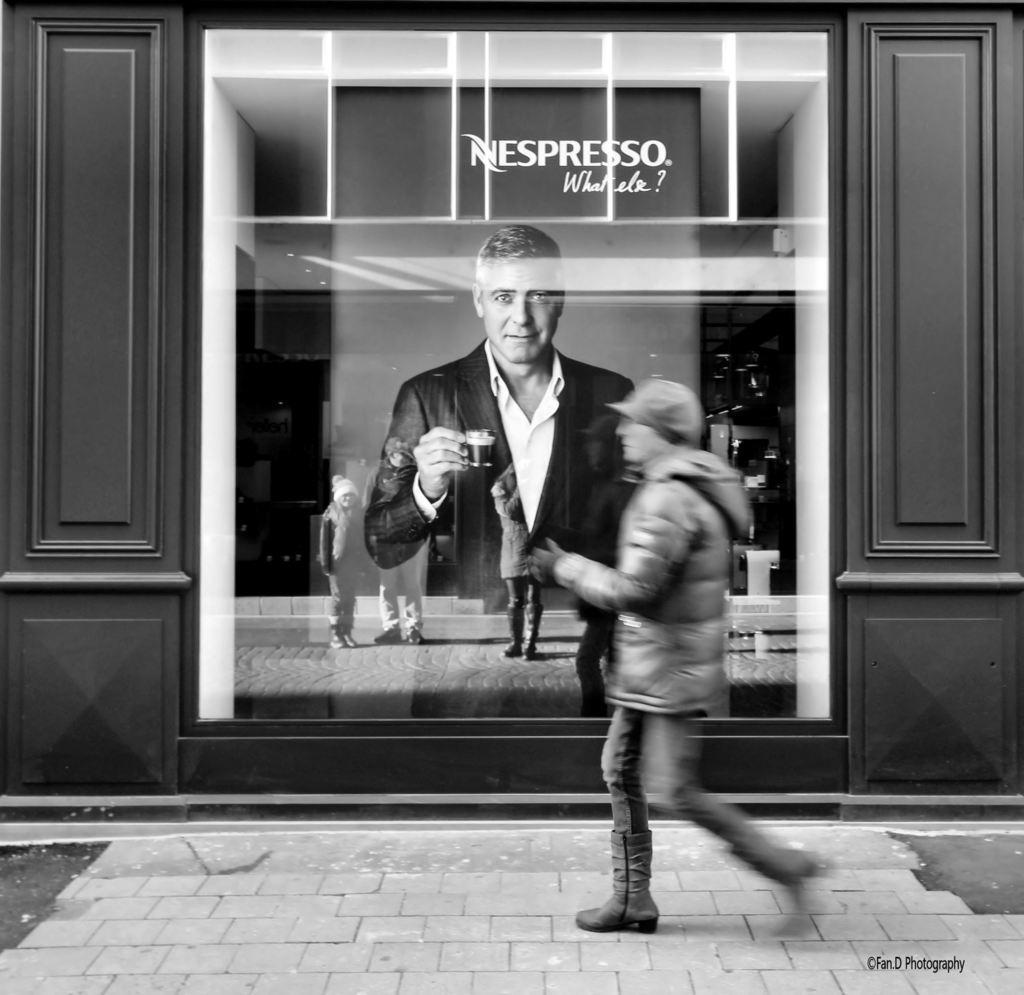In one or two sentences, can you explain what this image depicts? This is a black and white image. I can see a person walking. This looks like a poster of the man holding a cup. I think this poster is inside the building. I can see the reflection of few people standing in the glass. This looks like a wooden board. 